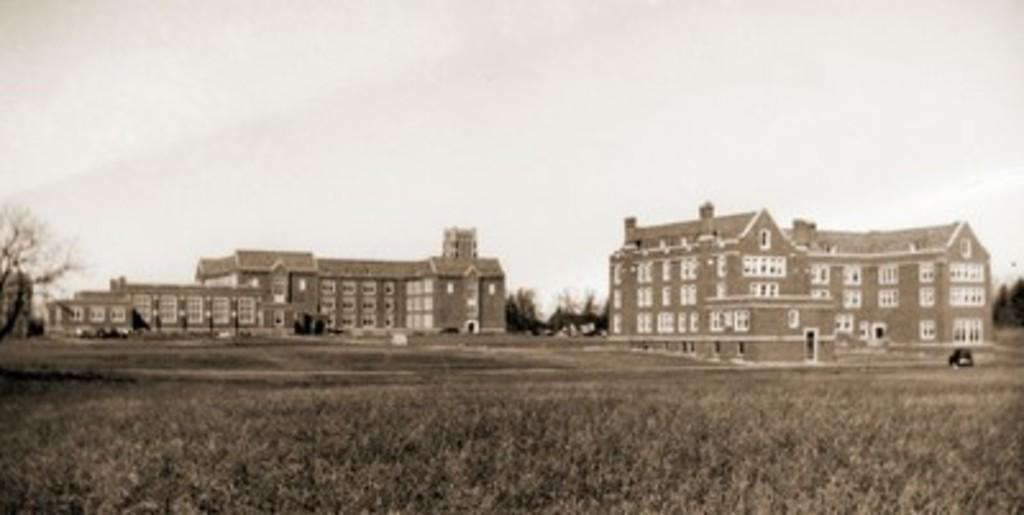What is the color scheme of the image? The image is black and white. How many buildings can be seen in the image? There are two buildings in the image. What type of terrain is the buildings located on? The buildings are on a grassland. What can be seen behind the buildings? There are trees behind the buildings. What type of humor is being displayed by the thing in the image? There is no humor or thing present in the image; it features two buildings on a grassland with trees in the background. 